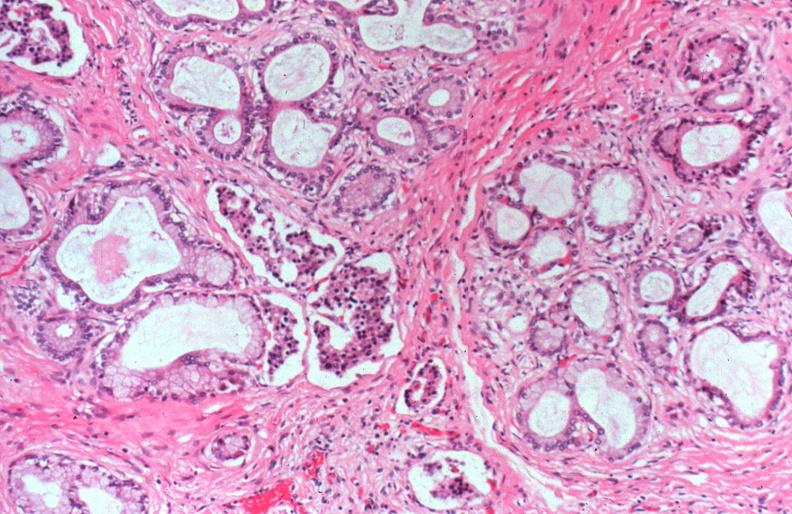does saggital section typical show cystic fibrosis?
Answer the question using a single word or phrase. No 